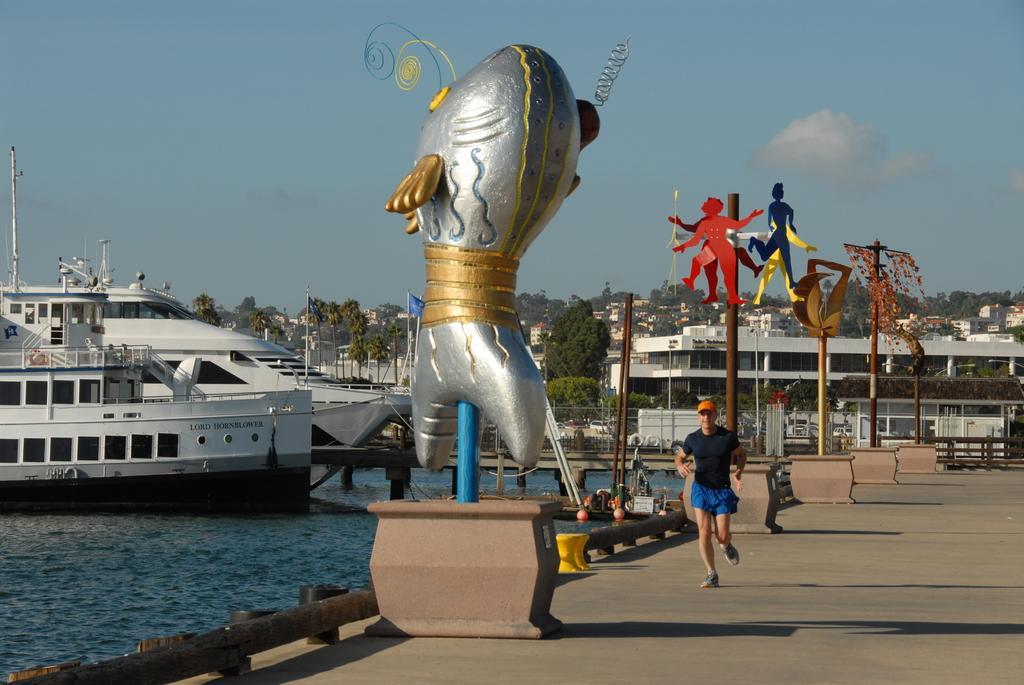Could you give a brief overview of what you see in this image? In this picture I can see person I can see there is a person running and there are ships in the water. There are poles, statue and there are some buildings and trees in the backdrop and the sky is clear. 